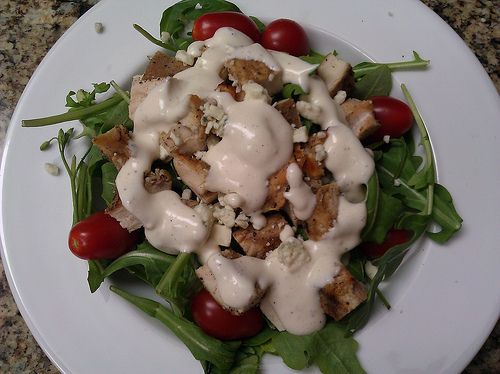<image>
Is there a tomato behind the plate? No. The tomato is not behind the plate. From this viewpoint, the tomato appears to be positioned elsewhere in the scene. 